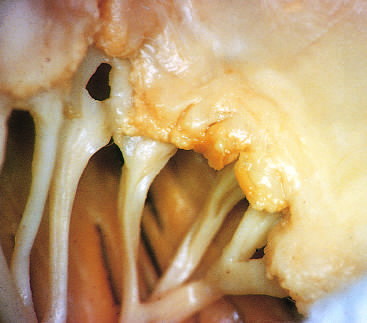re others, such as methylation of particular histone residues, visible along the line of closure of the mitral valve leaflets?
Answer the question using a single word or phrase. No 